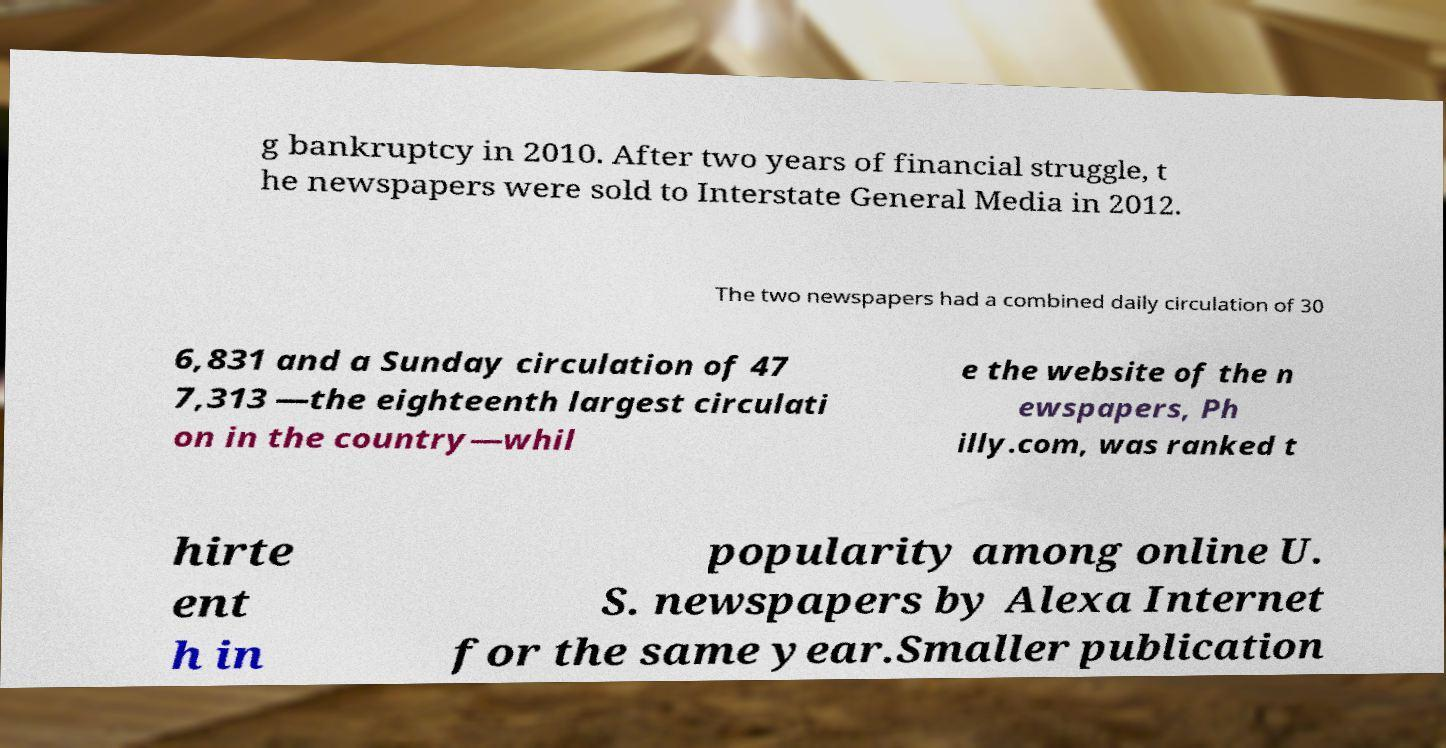Please identify and transcribe the text found in this image. g bankruptcy in 2010. After two years of financial struggle, t he newspapers were sold to Interstate General Media in 2012. The two newspapers had a combined daily circulation of 30 6,831 and a Sunday circulation of 47 7,313 —the eighteenth largest circulati on in the country—whil e the website of the n ewspapers, Ph illy.com, was ranked t hirte ent h in popularity among online U. S. newspapers by Alexa Internet for the same year.Smaller publication 